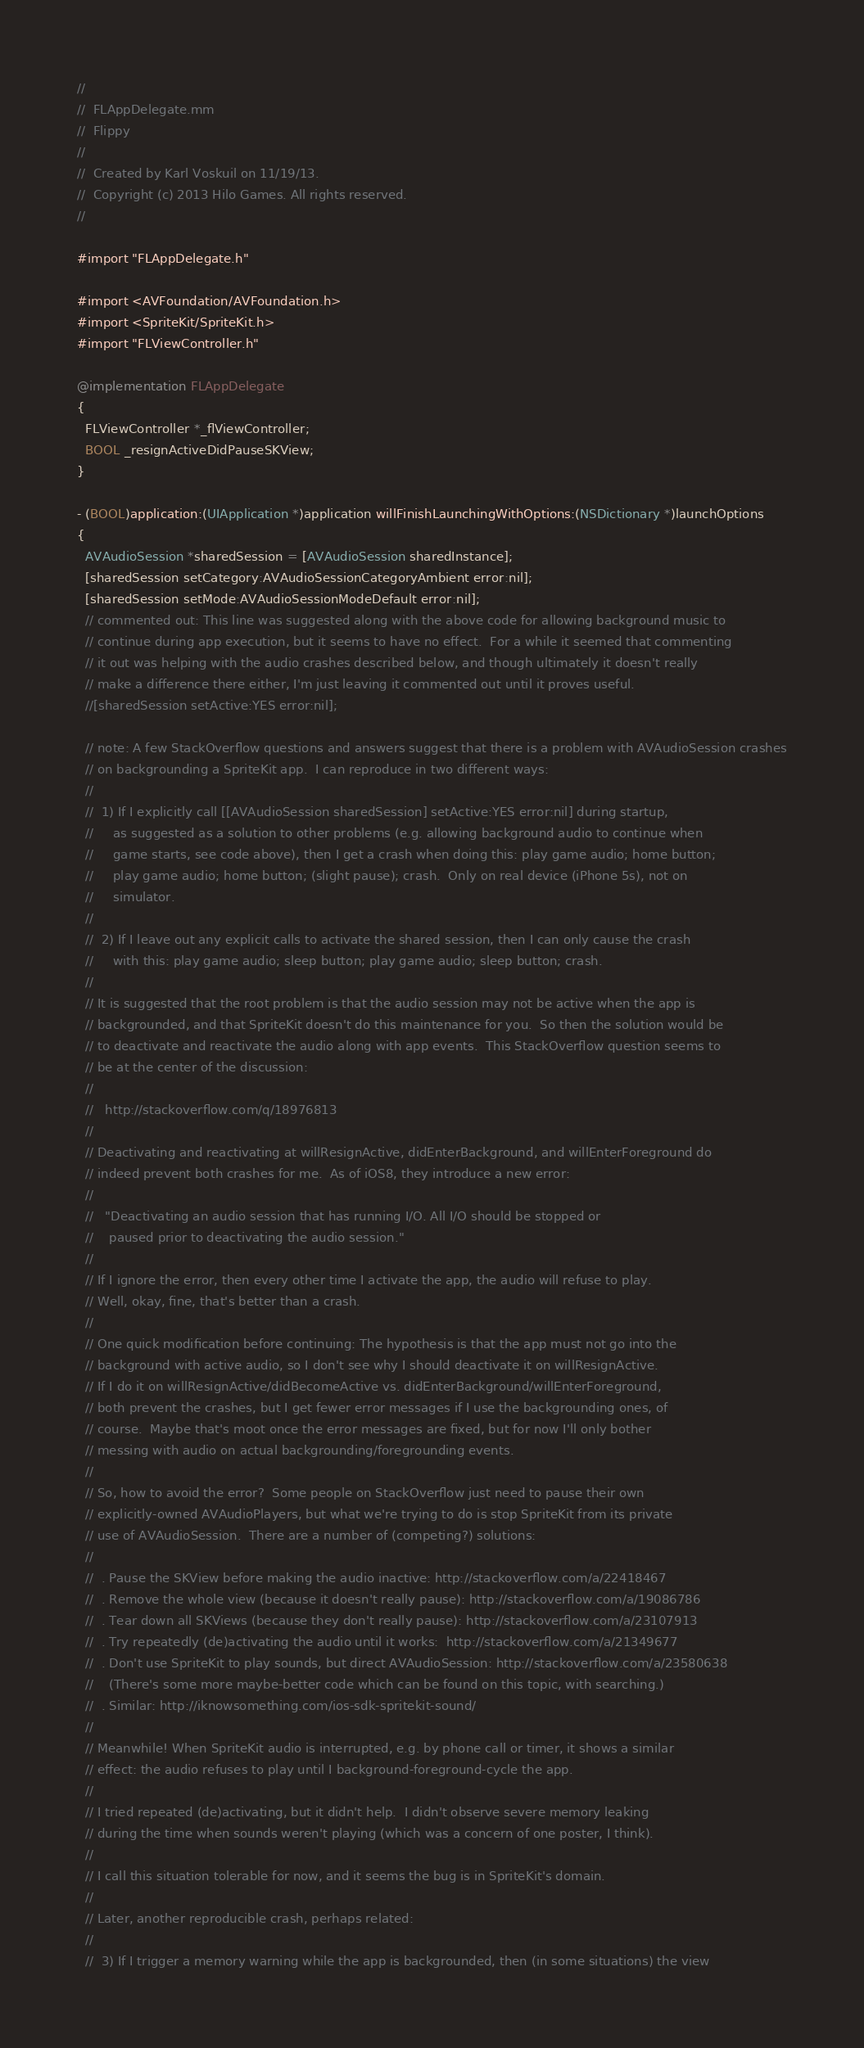Convert code to text. <code><loc_0><loc_0><loc_500><loc_500><_ObjectiveC_>//
//  FLAppDelegate.mm
//  Flippy
//
//  Created by Karl Voskuil on 11/19/13.
//  Copyright (c) 2013 Hilo Games. All rights reserved.
//

#import "FLAppDelegate.h"

#import <AVFoundation/AVFoundation.h>
#import <SpriteKit/SpriteKit.h>
#import "FLViewController.h"

@implementation FLAppDelegate
{
  FLViewController *_flViewController;
  BOOL _resignActiveDidPauseSKView;
}

- (BOOL)application:(UIApplication *)application willFinishLaunchingWithOptions:(NSDictionary *)launchOptions
{
  AVAudioSession *sharedSession = [AVAudioSession sharedInstance];
  [sharedSession setCategory:AVAudioSessionCategoryAmbient error:nil];
  [sharedSession setMode:AVAudioSessionModeDefault error:nil];
  // commented out: This line was suggested along with the above code for allowing background music to
  // continue during app execution, but it seems to have no effect.  For a while it seemed that commenting
  // it out was helping with the audio crashes described below, and though ultimately it doesn't really
  // make a difference there either, I'm just leaving it commented out until it proves useful.
  //[sharedSession setActive:YES error:nil];

  // note: A few StackOverflow questions and answers suggest that there is a problem with AVAudioSession crashes
  // on backgrounding a SpriteKit app.  I can reproduce in two different ways:
  //
  //  1) If I explicitly call [[AVAudioSession sharedSession] setActive:YES error:nil] during startup,
  //     as suggested as a solution to other problems (e.g. allowing background audio to continue when
  //     game starts, see code above), then I get a crash when doing this: play game audio; home button;
  //     play game audio; home button; (slight pause); crash.  Only on real device (iPhone 5s), not on
  //     simulator.
  //
  //  2) If I leave out any explicit calls to activate the shared session, then I can only cause the crash
  //     with this: play game audio; sleep button; play game audio; sleep button; crash.
  //
  // It is suggested that the root problem is that the audio session may not be active when the app is
  // backgrounded, and that SpriteKit doesn't do this maintenance for you.  So then the solution would be
  // to deactivate and reactivate the audio along with app events.  This StackOverflow question seems to
  // be at the center of the discussion:
  //
  //   http://stackoverflow.com/q/18976813
  //
  // Deactivating and reactivating at willResignActive, didEnterBackground, and willEnterForeground do
  // indeed prevent both crashes for me.  As of iOS8, they introduce a new error:
  //
  //   "Deactivating an audio session that has running I/O. All I/O should be stopped or
  //    paused prior to deactivating the audio session."
  //
  // If I ignore the error, then every other time I activate the app, the audio will refuse to play.
  // Well, okay, fine, that's better than a crash.
  //
  // One quick modification before continuing: The hypothesis is that the app must not go into the
  // background with active audio, so I don't see why I should deactivate it on willResignActive.
  // If I do it on willResignActive/didBecomeActive vs. didEnterBackground/willEnterForeground,
  // both prevent the crashes, but I get fewer error messages if I use the backgrounding ones, of
  // course.  Maybe that's moot once the error messages are fixed, but for now I'll only bother
  // messing with audio on actual backgrounding/foregrounding events.
  //
  // So, how to avoid the error?  Some people on StackOverflow just need to pause their own
  // explicitly-owned AVAudioPlayers, but what we're trying to do is stop SpriteKit from its private
  // use of AVAudioSession.  There are a number of (competing?) solutions:
  //
  //  . Pause the SKView before making the audio inactive: http://stackoverflow.com/a/22418467
  //  . Remove the whole view (because it doesn't really pause): http://stackoverflow.com/a/19086786
  //  . Tear down all SKViews (because they don't really pause): http://stackoverflow.com/a/23107913
  //  . Try repeatedly (de)activating the audio until it works:  http://stackoverflow.com/a/21349677
  //  . Don't use SpriteKit to play sounds, but direct AVAudioSession: http://stackoverflow.com/a/23580638
  //    (There's some more maybe-better code which can be found on this topic, with searching.)
  //  . Similar: http://iknowsomething.com/ios-sdk-spritekit-sound/
  //
  // Meanwhile! When SpriteKit audio is interrupted, e.g. by phone call or timer, it shows a similar
  // effect: the audio refuses to play until I background-foreground-cycle the app.
  //
  // I tried repeated (de)activating, but it didn't help.  I didn't observe severe memory leaking
  // during the time when sounds weren't playing (which was a concern of one poster, I think).
  //
  // I call this situation tolerable for now, and it seems the bug is in SpriteKit's domain.
  //
  // Later, another reproducible crash, perhaps related:
  //
  //  3) If I trigger a memory warning while the app is backgrounded, then (in some situations) the view</code> 